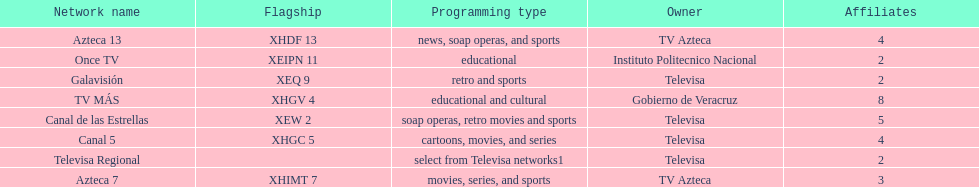Could you help me parse every detail presented in this table? {'header': ['Network name', 'Flagship', 'Programming type', 'Owner', 'Affiliates'], 'rows': [['Azteca 13', 'XHDF 13', 'news, soap operas, and sports', 'TV Azteca', '4'], ['Once TV', 'XEIPN 11', 'educational', 'Instituto Politecnico Nacional', '2'], ['Galavisión', 'XEQ 9', 'retro and sports', 'Televisa', '2'], ['TV MÁS', 'XHGV 4', 'educational and cultural', 'Gobierno de Veracruz', '8'], ['Canal de las Estrellas', 'XEW 2', 'soap operas, retro movies and sports', 'Televisa', '5'], ['Canal 5', 'XHGC 5', 'cartoons, movies, and series', 'Televisa', '4'], ['Televisa Regional', '', 'select from Televisa networks1', 'Televisa', '2'], ['Azteca 7', 'XHIMT 7', 'movies, series, and sports', 'TV Azteca', '3']]} How many networks show soap operas? 2. 